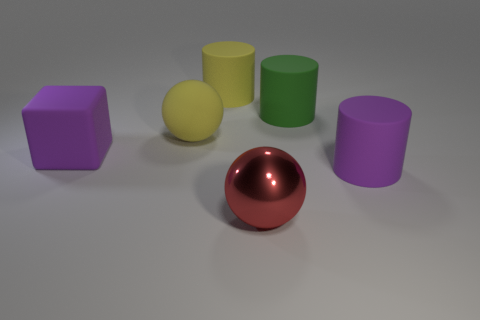There is a object that is the same color as the matte ball; what is its material?
Give a very brief answer. Rubber. Is there anything else that has the same shape as the big green thing?
Offer a very short reply. Yes. There is a big purple matte object that is in front of the purple thing behind the rubber cylinder in front of the big green cylinder; what shape is it?
Keep it short and to the point. Cylinder. What is the shape of the red metallic thing?
Keep it short and to the point. Sphere. The cylinder behind the large green thing is what color?
Make the answer very short. Yellow. Is the size of the purple matte thing that is in front of the cube the same as the large cube?
Offer a terse response. Yes. The purple thing that is the same shape as the green object is what size?
Offer a terse response. Large. Is there anything else that has the same size as the metal object?
Your response must be concise. Yes. Does the red object have the same shape as the large green rubber object?
Make the answer very short. No. Is the number of big purple matte blocks on the right side of the block less than the number of rubber objects that are in front of the big purple matte cylinder?
Your answer should be compact. No. 